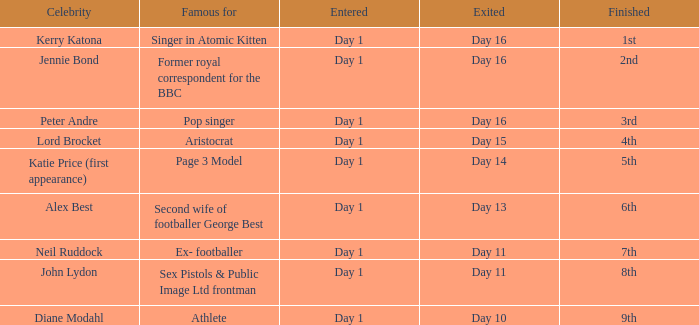Name who was famous for finished in 9th Athlete. 